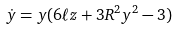Convert formula to latex. <formula><loc_0><loc_0><loc_500><loc_500>\dot { y } = y ( 6 \ell z + 3 R ^ { 2 } y ^ { 2 } - 3 )</formula> 